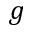<formula> <loc_0><loc_0><loc_500><loc_500>g</formula> 